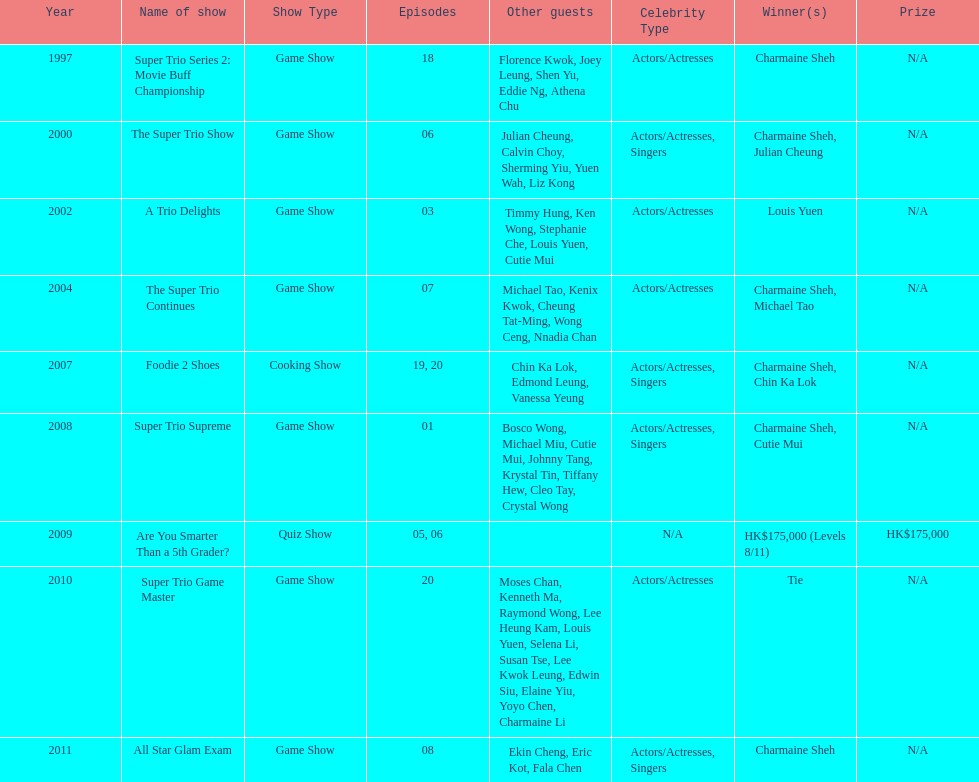How long has it been since chermaine sheh first appeared on a variety show? 17 years. 